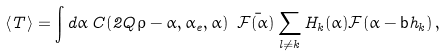Convert formula to latex. <formula><loc_0><loc_0><loc_500><loc_500>\langle T \rangle = \int d \alpha \, C ( 2 Q \rho - \alpha , \alpha _ { e } , \alpha ) \ \bar { \mathcal { F } ( \alpha ) } \sum _ { l \neq k } H _ { k } ( \alpha ) \mathcal { F } ( \alpha - \mathsf b h _ { k } ) \, ,</formula> 